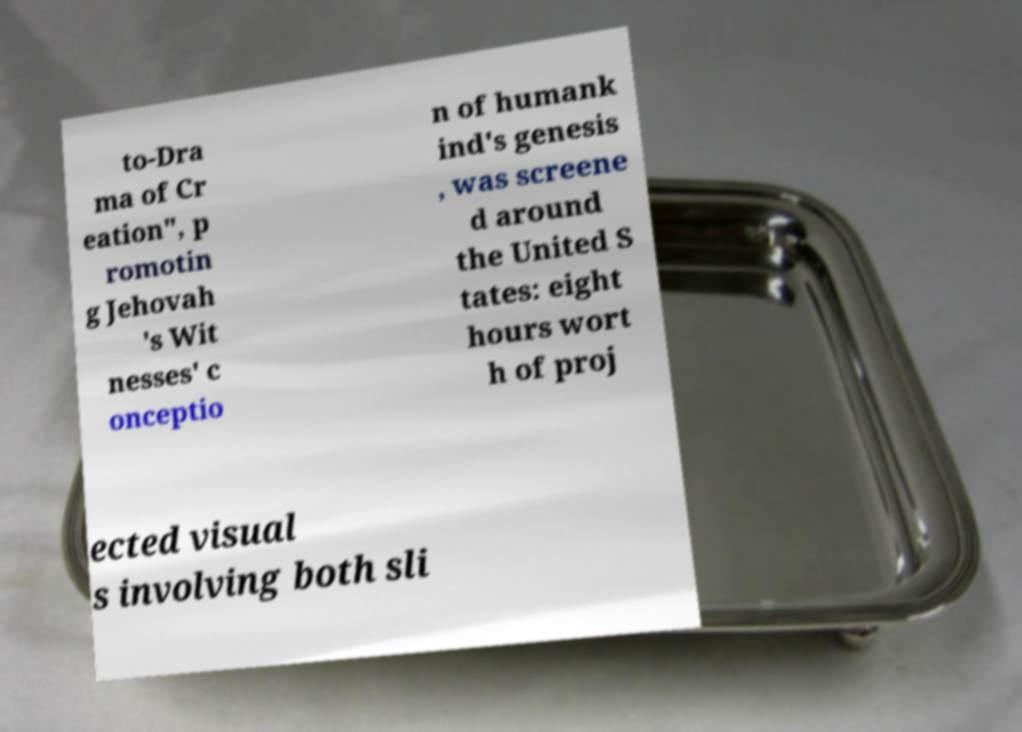Can you read and provide the text displayed in the image?This photo seems to have some interesting text. Can you extract and type it out for me? to-Dra ma of Cr eation", p romotin g Jehovah 's Wit nesses' c onceptio n of humank ind's genesis , was screene d around the United S tates: eight hours wort h of proj ected visual s involving both sli 